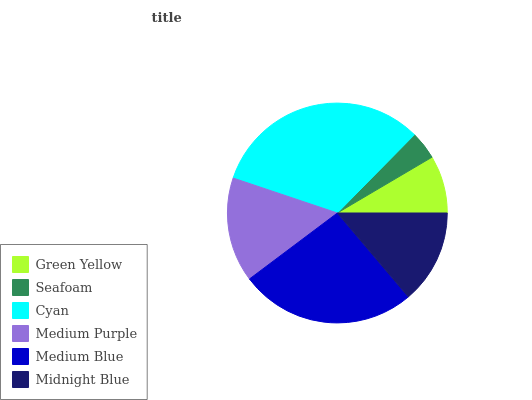Is Seafoam the minimum?
Answer yes or no. Yes. Is Cyan the maximum?
Answer yes or no. Yes. Is Cyan the minimum?
Answer yes or no. No. Is Seafoam the maximum?
Answer yes or no. No. Is Cyan greater than Seafoam?
Answer yes or no. Yes. Is Seafoam less than Cyan?
Answer yes or no. Yes. Is Seafoam greater than Cyan?
Answer yes or no. No. Is Cyan less than Seafoam?
Answer yes or no. No. Is Medium Purple the high median?
Answer yes or no. Yes. Is Midnight Blue the low median?
Answer yes or no. Yes. Is Seafoam the high median?
Answer yes or no. No. Is Medium Blue the low median?
Answer yes or no. No. 